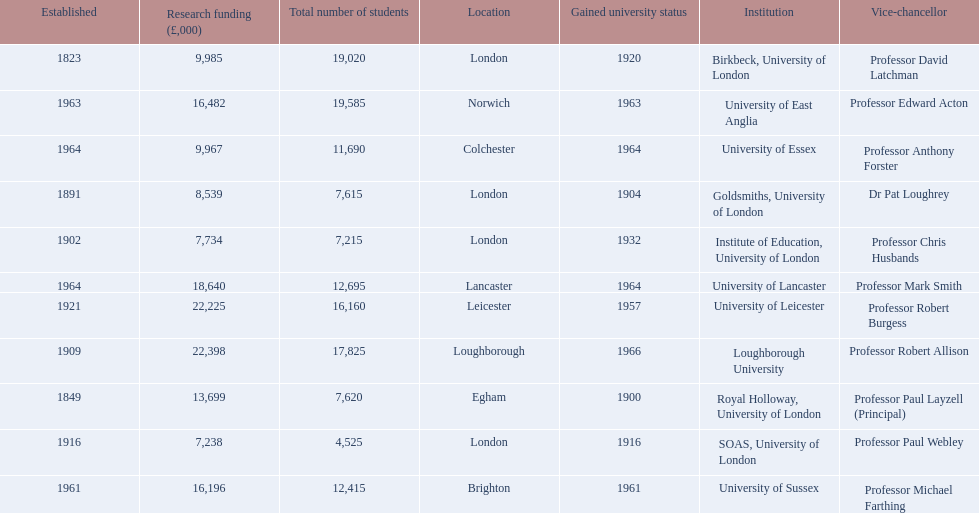Where is birbeck,university of london located? London. Which university was established in 1921? University of Leicester. Which institution gained university status recently? Loughborough University. 